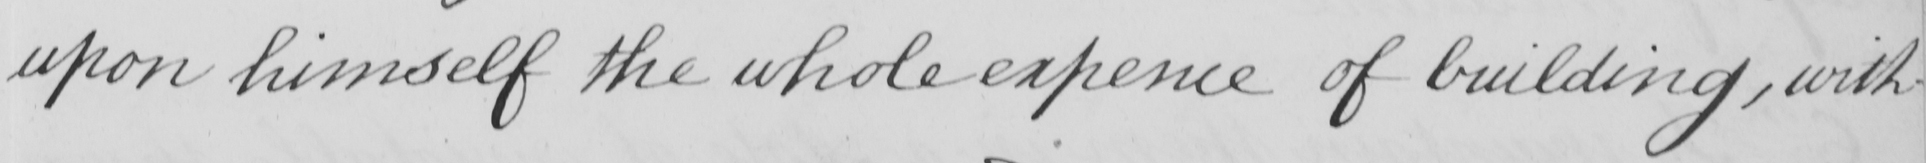What text is written in this handwritten line? upon himself the whole expence of building , with 